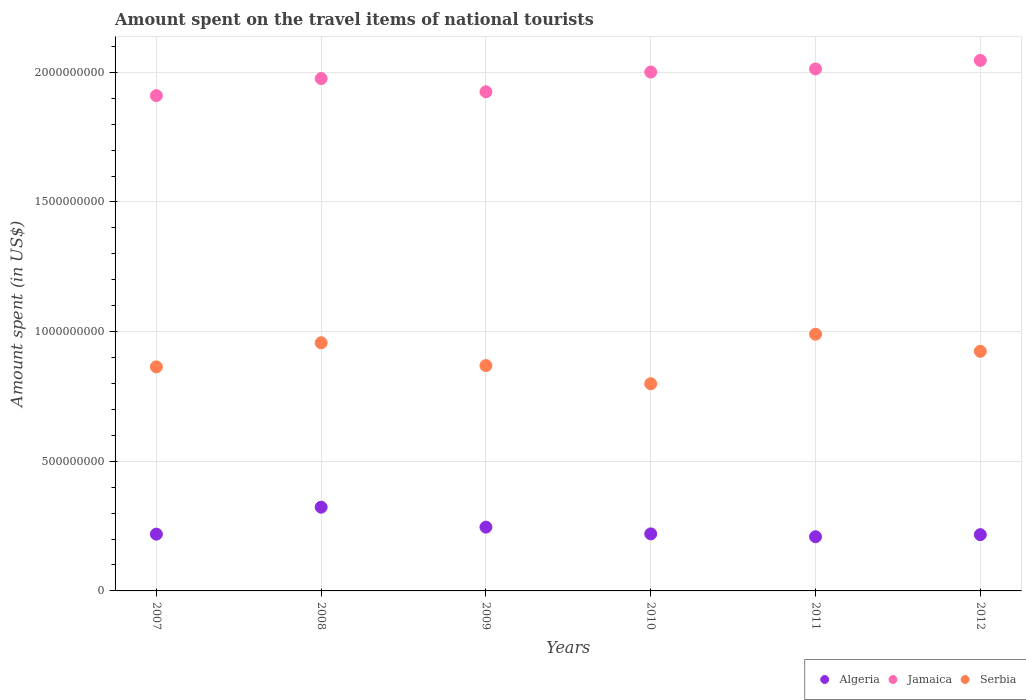What is the amount spent on the travel items of national tourists in Serbia in 2011?
Offer a very short reply. 9.90e+08. Across all years, what is the maximum amount spent on the travel items of national tourists in Serbia?
Provide a short and direct response. 9.90e+08. Across all years, what is the minimum amount spent on the travel items of national tourists in Serbia?
Offer a terse response. 7.99e+08. In which year was the amount spent on the travel items of national tourists in Jamaica maximum?
Your answer should be very brief. 2012. In which year was the amount spent on the travel items of national tourists in Jamaica minimum?
Your response must be concise. 2007. What is the total amount spent on the travel items of national tourists in Algeria in the graph?
Your answer should be compact. 1.43e+09. What is the difference between the amount spent on the travel items of national tourists in Jamaica in 2010 and that in 2012?
Make the answer very short. -4.50e+07. What is the difference between the amount spent on the travel items of national tourists in Jamaica in 2011 and the amount spent on the travel items of national tourists in Algeria in 2009?
Provide a short and direct response. 1.77e+09. What is the average amount spent on the travel items of national tourists in Algeria per year?
Provide a succinct answer. 2.39e+08. In the year 2011, what is the difference between the amount spent on the travel items of national tourists in Serbia and amount spent on the travel items of national tourists in Algeria?
Your answer should be compact. 7.81e+08. What is the ratio of the amount spent on the travel items of national tourists in Jamaica in 2009 to that in 2011?
Make the answer very short. 0.96. Is the amount spent on the travel items of national tourists in Serbia in 2007 less than that in 2008?
Your answer should be very brief. Yes. Is the difference between the amount spent on the travel items of national tourists in Serbia in 2009 and 2011 greater than the difference between the amount spent on the travel items of national tourists in Algeria in 2009 and 2011?
Make the answer very short. No. What is the difference between the highest and the second highest amount spent on the travel items of national tourists in Serbia?
Provide a short and direct response. 3.30e+07. What is the difference between the highest and the lowest amount spent on the travel items of national tourists in Serbia?
Your response must be concise. 1.91e+08. In how many years, is the amount spent on the travel items of national tourists in Serbia greater than the average amount spent on the travel items of national tourists in Serbia taken over all years?
Give a very brief answer. 3. Is the sum of the amount spent on the travel items of national tourists in Jamaica in 2009 and 2012 greater than the maximum amount spent on the travel items of national tourists in Algeria across all years?
Ensure brevity in your answer.  Yes. Is the amount spent on the travel items of national tourists in Serbia strictly less than the amount spent on the travel items of national tourists in Algeria over the years?
Your answer should be very brief. No. How many years are there in the graph?
Keep it short and to the point. 6. What is the difference between two consecutive major ticks on the Y-axis?
Keep it short and to the point. 5.00e+08. Are the values on the major ticks of Y-axis written in scientific E-notation?
Keep it short and to the point. No. Does the graph contain grids?
Provide a short and direct response. Yes. Where does the legend appear in the graph?
Ensure brevity in your answer.  Bottom right. What is the title of the graph?
Keep it short and to the point. Amount spent on the travel items of national tourists. Does "Brazil" appear as one of the legend labels in the graph?
Keep it short and to the point. No. What is the label or title of the Y-axis?
Ensure brevity in your answer.  Amount spent (in US$). What is the Amount spent (in US$) in Algeria in 2007?
Provide a short and direct response. 2.19e+08. What is the Amount spent (in US$) in Jamaica in 2007?
Give a very brief answer. 1.91e+09. What is the Amount spent (in US$) in Serbia in 2007?
Offer a very short reply. 8.64e+08. What is the Amount spent (in US$) of Algeria in 2008?
Make the answer very short. 3.23e+08. What is the Amount spent (in US$) of Jamaica in 2008?
Offer a terse response. 1.98e+09. What is the Amount spent (in US$) in Serbia in 2008?
Keep it short and to the point. 9.57e+08. What is the Amount spent (in US$) of Algeria in 2009?
Keep it short and to the point. 2.46e+08. What is the Amount spent (in US$) in Jamaica in 2009?
Your answer should be compact. 1.92e+09. What is the Amount spent (in US$) in Serbia in 2009?
Your answer should be compact. 8.69e+08. What is the Amount spent (in US$) of Algeria in 2010?
Your answer should be compact. 2.20e+08. What is the Amount spent (in US$) of Jamaica in 2010?
Make the answer very short. 2.00e+09. What is the Amount spent (in US$) in Serbia in 2010?
Offer a very short reply. 7.99e+08. What is the Amount spent (in US$) in Algeria in 2011?
Offer a very short reply. 2.09e+08. What is the Amount spent (in US$) in Jamaica in 2011?
Your response must be concise. 2.01e+09. What is the Amount spent (in US$) in Serbia in 2011?
Ensure brevity in your answer.  9.90e+08. What is the Amount spent (in US$) in Algeria in 2012?
Your response must be concise. 2.17e+08. What is the Amount spent (in US$) in Jamaica in 2012?
Ensure brevity in your answer.  2.05e+09. What is the Amount spent (in US$) of Serbia in 2012?
Make the answer very short. 9.24e+08. Across all years, what is the maximum Amount spent (in US$) in Algeria?
Make the answer very short. 3.23e+08. Across all years, what is the maximum Amount spent (in US$) in Jamaica?
Offer a terse response. 2.05e+09. Across all years, what is the maximum Amount spent (in US$) of Serbia?
Ensure brevity in your answer.  9.90e+08. Across all years, what is the minimum Amount spent (in US$) in Algeria?
Provide a short and direct response. 2.09e+08. Across all years, what is the minimum Amount spent (in US$) of Jamaica?
Your response must be concise. 1.91e+09. Across all years, what is the minimum Amount spent (in US$) of Serbia?
Keep it short and to the point. 7.99e+08. What is the total Amount spent (in US$) in Algeria in the graph?
Give a very brief answer. 1.43e+09. What is the total Amount spent (in US$) in Jamaica in the graph?
Give a very brief answer. 1.19e+1. What is the total Amount spent (in US$) in Serbia in the graph?
Offer a terse response. 5.40e+09. What is the difference between the Amount spent (in US$) of Algeria in 2007 and that in 2008?
Offer a terse response. -1.04e+08. What is the difference between the Amount spent (in US$) of Jamaica in 2007 and that in 2008?
Ensure brevity in your answer.  -6.60e+07. What is the difference between the Amount spent (in US$) in Serbia in 2007 and that in 2008?
Your response must be concise. -9.30e+07. What is the difference between the Amount spent (in US$) of Algeria in 2007 and that in 2009?
Your response must be concise. -2.70e+07. What is the difference between the Amount spent (in US$) of Jamaica in 2007 and that in 2009?
Your answer should be very brief. -1.50e+07. What is the difference between the Amount spent (in US$) of Serbia in 2007 and that in 2009?
Your answer should be compact. -5.00e+06. What is the difference between the Amount spent (in US$) of Jamaica in 2007 and that in 2010?
Offer a terse response. -9.10e+07. What is the difference between the Amount spent (in US$) of Serbia in 2007 and that in 2010?
Keep it short and to the point. 6.50e+07. What is the difference between the Amount spent (in US$) of Jamaica in 2007 and that in 2011?
Your answer should be very brief. -1.03e+08. What is the difference between the Amount spent (in US$) in Serbia in 2007 and that in 2011?
Offer a terse response. -1.26e+08. What is the difference between the Amount spent (in US$) in Jamaica in 2007 and that in 2012?
Provide a short and direct response. -1.36e+08. What is the difference between the Amount spent (in US$) of Serbia in 2007 and that in 2012?
Give a very brief answer. -6.00e+07. What is the difference between the Amount spent (in US$) in Algeria in 2008 and that in 2009?
Keep it short and to the point. 7.70e+07. What is the difference between the Amount spent (in US$) of Jamaica in 2008 and that in 2009?
Your answer should be compact. 5.10e+07. What is the difference between the Amount spent (in US$) in Serbia in 2008 and that in 2009?
Provide a short and direct response. 8.80e+07. What is the difference between the Amount spent (in US$) in Algeria in 2008 and that in 2010?
Give a very brief answer. 1.03e+08. What is the difference between the Amount spent (in US$) in Jamaica in 2008 and that in 2010?
Keep it short and to the point. -2.50e+07. What is the difference between the Amount spent (in US$) in Serbia in 2008 and that in 2010?
Provide a succinct answer. 1.58e+08. What is the difference between the Amount spent (in US$) in Algeria in 2008 and that in 2011?
Your answer should be very brief. 1.14e+08. What is the difference between the Amount spent (in US$) in Jamaica in 2008 and that in 2011?
Make the answer very short. -3.70e+07. What is the difference between the Amount spent (in US$) of Serbia in 2008 and that in 2011?
Your answer should be very brief. -3.30e+07. What is the difference between the Amount spent (in US$) in Algeria in 2008 and that in 2012?
Make the answer very short. 1.06e+08. What is the difference between the Amount spent (in US$) in Jamaica in 2008 and that in 2012?
Offer a very short reply. -7.00e+07. What is the difference between the Amount spent (in US$) of Serbia in 2008 and that in 2012?
Your answer should be very brief. 3.30e+07. What is the difference between the Amount spent (in US$) in Algeria in 2009 and that in 2010?
Your answer should be compact. 2.60e+07. What is the difference between the Amount spent (in US$) in Jamaica in 2009 and that in 2010?
Ensure brevity in your answer.  -7.60e+07. What is the difference between the Amount spent (in US$) of Serbia in 2009 and that in 2010?
Your answer should be very brief. 7.00e+07. What is the difference between the Amount spent (in US$) of Algeria in 2009 and that in 2011?
Ensure brevity in your answer.  3.70e+07. What is the difference between the Amount spent (in US$) in Jamaica in 2009 and that in 2011?
Your response must be concise. -8.80e+07. What is the difference between the Amount spent (in US$) of Serbia in 2009 and that in 2011?
Provide a short and direct response. -1.21e+08. What is the difference between the Amount spent (in US$) of Algeria in 2009 and that in 2012?
Give a very brief answer. 2.90e+07. What is the difference between the Amount spent (in US$) of Jamaica in 2009 and that in 2012?
Your answer should be compact. -1.21e+08. What is the difference between the Amount spent (in US$) in Serbia in 2009 and that in 2012?
Offer a terse response. -5.50e+07. What is the difference between the Amount spent (in US$) of Algeria in 2010 and that in 2011?
Make the answer very short. 1.10e+07. What is the difference between the Amount spent (in US$) of Jamaica in 2010 and that in 2011?
Ensure brevity in your answer.  -1.20e+07. What is the difference between the Amount spent (in US$) of Serbia in 2010 and that in 2011?
Ensure brevity in your answer.  -1.91e+08. What is the difference between the Amount spent (in US$) in Jamaica in 2010 and that in 2012?
Ensure brevity in your answer.  -4.50e+07. What is the difference between the Amount spent (in US$) in Serbia in 2010 and that in 2012?
Your answer should be very brief. -1.25e+08. What is the difference between the Amount spent (in US$) of Algeria in 2011 and that in 2012?
Provide a short and direct response. -8.00e+06. What is the difference between the Amount spent (in US$) in Jamaica in 2011 and that in 2012?
Ensure brevity in your answer.  -3.30e+07. What is the difference between the Amount spent (in US$) in Serbia in 2011 and that in 2012?
Provide a short and direct response. 6.60e+07. What is the difference between the Amount spent (in US$) in Algeria in 2007 and the Amount spent (in US$) in Jamaica in 2008?
Your answer should be compact. -1.76e+09. What is the difference between the Amount spent (in US$) of Algeria in 2007 and the Amount spent (in US$) of Serbia in 2008?
Ensure brevity in your answer.  -7.38e+08. What is the difference between the Amount spent (in US$) in Jamaica in 2007 and the Amount spent (in US$) in Serbia in 2008?
Give a very brief answer. 9.53e+08. What is the difference between the Amount spent (in US$) in Algeria in 2007 and the Amount spent (in US$) in Jamaica in 2009?
Keep it short and to the point. -1.71e+09. What is the difference between the Amount spent (in US$) of Algeria in 2007 and the Amount spent (in US$) of Serbia in 2009?
Give a very brief answer. -6.50e+08. What is the difference between the Amount spent (in US$) in Jamaica in 2007 and the Amount spent (in US$) in Serbia in 2009?
Make the answer very short. 1.04e+09. What is the difference between the Amount spent (in US$) of Algeria in 2007 and the Amount spent (in US$) of Jamaica in 2010?
Your response must be concise. -1.78e+09. What is the difference between the Amount spent (in US$) in Algeria in 2007 and the Amount spent (in US$) in Serbia in 2010?
Your answer should be compact. -5.80e+08. What is the difference between the Amount spent (in US$) of Jamaica in 2007 and the Amount spent (in US$) of Serbia in 2010?
Provide a short and direct response. 1.11e+09. What is the difference between the Amount spent (in US$) of Algeria in 2007 and the Amount spent (in US$) of Jamaica in 2011?
Your answer should be very brief. -1.79e+09. What is the difference between the Amount spent (in US$) of Algeria in 2007 and the Amount spent (in US$) of Serbia in 2011?
Provide a succinct answer. -7.71e+08. What is the difference between the Amount spent (in US$) in Jamaica in 2007 and the Amount spent (in US$) in Serbia in 2011?
Offer a terse response. 9.20e+08. What is the difference between the Amount spent (in US$) in Algeria in 2007 and the Amount spent (in US$) in Jamaica in 2012?
Offer a very short reply. -1.83e+09. What is the difference between the Amount spent (in US$) of Algeria in 2007 and the Amount spent (in US$) of Serbia in 2012?
Make the answer very short. -7.05e+08. What is the difference between the Amount spent (in US$) of Jamaica in 2007 and the Amount spent (in US$) of Serbia in 2012?
Your answer should be compact. 9.86e+08. What is the difference between the Amount spent (in US$) of Algeria in 2008 and the Amount spent (in US$) of Jamaica in 2009?
Offer a very short reply. -1.60e+09. What is the difference between the Amount spent (in US$) in Algeria in 2008 and the Amount spent (in US$) in Serbia in 2009?
Offer a terse response. -5.46e+08. What is the difference between the Amount spent (in US$) of Jamaica in 2008 and the Amount spent (in US$) of Serbia in 2009?
Give a very brief answer. 1.11e+09. What is the difference between the Amount spent (in US$) in Algeria in 2008 and the Amount spent (in US$) in Jamaica in 2010?
Your answer should be very brief. -1.68e+09. What is the difference between the Amount spent (in US$) of Algeria in 2008 and the Amount spent (in US$) of Serbia in 2010?
Your answer should be very brief. -4.76e+08. What is the difference between the Amount spent (in US$) of Jamaica in 2008 and the Amount spent (in US$) of Serbia in 2010?
Keep it short and to the point. 1.18e+09. What is the difference between the Amount spent (in US$) in Algeria in 2008 and the Amount spent (in US$) in Jamaica in 2011?
Keep it short and to the point. -1.69e+09. What is the difference between the Amount spent (in US$) in Algeria in 2008 and the Amount spent (in US$) in Serbia in 2011?
Give a very brief answer. -6.67e+08. What is the difference between the Amount spent (in US$) of Jamaica in 2008 and the Amount spent (in US$) of Serbia in 2011?
Offer a terse response. 9.86e+08. What is the difference between the Amount spent (in US$) in Algeria in 2008 and the Amount spent (in US$) in Jamaica in 2012?
Make the answer very short. -1.72e+09. What is the difference between the Amount spent (in US$) of Algeria in 2008 and the Amount spent (in US$) of Serbia in 2012?
Your response must be concise. -6.01e+08. What is the difference between the Amount spent (in US$) of Jamaica in 2008 and the Amount spent (in US$) of Serbia in 2012?
Your answer should be very brief. 1.05e+09. What is the difference between the Amount spent (in US$) in Algeria in 2009 and the Amount spent (in US$) in Jamaica in 2010?
Give a very brief answer. -1.76e+09. What is the difference between the Amount spent (in US$) in Algeria in 2009 and the Amount spent (in US$) in Serbia in 2010?
Offer a terse response. -5.53e+08. What is the difference between the Amount spent (in US$) of Jamaica in 2009 and the Amount spent (in US$) of Serbia in 2010?
Your response must be concise. 1.13e+09. What is the difference between the Amount spent (in US$) of Algeria in 2009 and the Amount spent (in US$) of Jamaica in 2011?
Provide a succinct answer. -1.77e+09. What is the difference between the Amount spent (in US$) of Algeria in 2009 and the Amount spent (in US$) of Serbia in 2011?
Your answer should be very brief. -7.44e+08. What is the difference between the Amount spent (in US$) in Jamaica in 2009 and the Amount spent (in US$) in Serbia in 2011?
Ensure brevity in your answer.  9.35e+08. What is the difference between the Amount spent (in US$) of Algeria in 2009 and the Amount spent (in US$) of Jamaica in 2012?
Ensure brevity in your answer.  -1.80e+09. What is the difference between the Amount spent (in US$) of Algeria in 2009 and the Amount spent (in US$) of Serbia in 2012?
Offer a terse response. -6.78e+08. What is the difference between the Amount spent (in US$) of Jamaica in 2009 and the Amount spent (in US$) of Serbia in 2012?
Your response must be concise. 1.00e+09. What is the difference between the Amount spent (in US$) of Algeria in 2010 and the Amount spent (in US$) of Jamaica in 2011?
Offer a very short reply. -1.79e+09. What is the difference between the Amount spent (in US$) in Algeria in 2010 and the Amount spent (in US$) in Serbia in 2011?
Provide a succinct answer. -7.70e+08. What is the difference between the Amount spent (in US$) in Jamaica in 2010 and the Amount spent (in US$) in Serbia in 2011?
Your answer should be very brief. 1.01e+09. What is the difference between the Amount spent (in US$) of Algeria in 2010 and the Amount spent (in US$) of Jamaica in 2012?
Your answer should be compact. -1.83e+09. What is the difference between the Amount spent (in US$) of Algeria in 2010 and the Amount spent (in US$) of Serbia in 2012?
Ensure brevity in your answer.  -7.04e+08. What is the difference between the Amount spent (in US$) of Jamaica in 2010 and the Amount spent (in US$) of Serbia in 2012?
Ensure brevity in your answer.  1.08e+09. What is the difference between the Amount spent (in US$) of Algeria in 2011 and the Amount spent (in US$) of Jamaica in 2012?
Your response must be concise. -1.84e+09. What is the difference between the Amount spent (in US$) in Algeria in 2011 and the Amount spent (in US$) in Serbia in 2012?
Your answer should be compact. -7.15e+08. What is the difference between the Amount spent (in US$) in Jamaica in 2011 and the Amount spent (in US$) in Serbia in 2012?
Your answer should be compact. 1.09e+09. What is the average Amount spent (in US$) of Algeria per year?
Your answer should be very brief. 2.39e+08. What is the average Amount spent (in US$) of Jamaica per year?
Provide a short and direct response. 1.98e+09. What is the average Amount spent (in US$) in Serbia per year?
Your answer should be compact. 9.00e+08. In the year 2007, what is the difference between the Amount spent (in US$) of Algeria and Amount spent (in US$) of Jamaica?
Provide a succinct answer. -1.69e+09. In the year 2007, what is the difference between the Amount spent (in US$) of Algeria and Amount spent (in US$) of Serbia?
Offer a very short reply. -6.45e+08. In the year 2007, what is the difference between the Amount spent (in US$) of Jamaica and Amount spent (in US$) of Serbia?
Provide a short and direct response. 1.05e+09. In the year 2008, what is the difference between the Amount spent (in US$) in Algeria and Amount spent (in US$) in Jamaica?
Ensure brevity in your answer.  -1.65e+09. In the year 2008, what is the difference between the Amount spent (in US$) of Algeria and Amount spent (in US$) of Serbia?
Your answer should be compact. -6.34e+08. In the year 2008, what is the difference between the Amount spent (in US$) of Jamaica and Amount spent (in US$) of Serbia?
Offer a terse response. 1.02e+09. In the year 2009, what is the difference between the Amount spent (in US$) in Algeria and Amount spent (in US$) in Jamaica?
Offer a very short reply. -1.68e+09. In the year 2009, what is the difference between the Amount spent (in US$) in Algeria and Amount spent (in US$) in Serbia?
Give a very brief answer. -6.23e+08. In the year 2009, what is the difference between the Amount spent (in US$) in Jamaica and Amount spent (in US$) in Serbia?
Give a very brief answer. 1.06e+09. In the year 2010, what is the difference between the Amount spent (in US$) of Algeria and Amount spent (in US$) of Jamaica?
Offer a terse response. -1.78e+09. In the year 2010, what is the difference between the Amount spent (in US$) in Algeria and Amount spent (in US$) in Serbia?
Provide a short and direct response. -5.79e+08. In the year 2010, what is the difference between the Amount spent (in US$) in Jamaica and Amount spent (in US$) in Serbia?
Your answer should be compact. 1.20e+09. In the year 2011, what is the difference between the Amount spent (in US$) in Algeria and Amount spent (in US$) in Jamaica?
Provide a succinct answer. -1.80e+09. In the year 2011, what is the difference between the Amount spent (in US$) of Algeria and Amount spent (in US$) of Serbia?
Provide a short and direct response. -7.81e+08. In the year 2011, what is the difference between the Amount spent (in US$) of Jamaica and Amount spent (in US$) of Serbia?
Offer a terse response. 1.02e+09. In the year 2012, what is the difference between the Amount spent (in US$) of Algeria and Amount spent (in US$) of Jamaica?
Give a very brief answer. -1.83e+09. In the year 2012, what is the difference between the Amount spent (in US$) in Algeria and Amount spent (in US$) in Serbia?
Your answer should be compact. -7.07e+08. In the year 2012, what is the difference between the Amount spent (in US$) in Jamaica and Amount spent (in US$) in Serbia?
Provide a short and direct response. 1.12e+09. What is the ratio of the Amount spent (in US$) of Algeria in 2007 to that in 2008?
Your answer should be very brief. 0.68. What is the ratio of the Amount spent (in US$) in Jamaica in 2007 to that in 2008?
Offer a terse response. 0.97. What is the ratio of the Amount spent (in US$) in Serbia in 2007 to that in 2008?
Your response must be concise. 0.9. What is the ratio of the Amount spent (in US$) of Algeria in 2007 to that in 2009?
Make the answer very short. 0.89. What is the ratio of the Amount spent (in US$) in Algeria in 2007 to that in 2010?
Your response must be concise. 1. What is the ratio of the Amount spent (in US$) in Jamaica in 2007 to that in 2010?
Offer a very short reply. 0.95. What is the ratio of the Amount spent (in US$) in Serbia in 2007 to that in 2010?
Provide a short and direct response. 1.08. What is the ratio of the Amount spent (in US$) in Algeria in 2007 to that in 2011?
Offer a very short reply. 1.05. What is the ratio of the Amount spent (in US$) of Jamaica in 2007 to that in 2011?
Keep it short and to the point. 0.95. What is the ratio of the Amount spent (in US$) of Serbia in 2007 to that in 2011?
Your response must be concise. 0.87. What is the ratio of the Amount spent (in US$) of Algeria in 2007 to that in 2012?
Make the answer very short. 1.01. What is the ratio of the Amount spent (in US$) in Jamaica in 2007 to that in 2012?
Provide a succinct answer. 0.93. What is the ratio of the Amount spent (in US$) of Serbia in 2007 to that in 2012?
Your response must be concise. 0.94. What is the ratio of the Amount spent (in US$) in Algeria in 2008 to that in 2009?
Give a very brief answer. 1.31. What is the ratio of the Amount spent (in US$) in Jamaica in 2008 to that in 2009?
Give a very brief answer. 1.03. What is the ratio of the Amount spent (in US$) of Serbia in 2008 to that in 2009?
Give a very brief answer. 1.1. What is the ratio of the Amount spent (in US$) of Algeria in 2008 to that in 2010?
Make the answer very short. 1.47. What is the ratio of the Amount spent (in US$) in Jamaica in 2008 to that in 2010?
Your response must be concise. 0.99. What is the ratio of the Amount spent (in US$) in Serbia in 2008 to that in 2010?
Your answer should be compact. 1.2. What is the ratio of the Amount spent (in US$) of Algeria in 2008 to that in 2011?
Give a very brief answer. 1.55. What is the ratio of the Amount spent (in US$) of Jamaica in 2008 to that in 2011?
Make the answer very short. 0.98. What is the ratio of the Amount spent (in US$) of Serbia in 2008 to that in 2011?
Your response must be concise. 0.97. What is the ratio of the Amount spent (in US$) in Algeria in 2008 to that in 2012?
Your response must be concise. 1.49. What is the ratio of the Amount spent (in US$) in Jamaica in 2008 to that in 2012?
Your response must be concise. 0.97. What is the ratio of the Amount spent (in US$) of Serbia in 2008 to that in 2012?
Provide a short and direct response. 1.04. What is the ratio of the Amount spent (in US$) in Algeria in 2009 to that in 2010?
Provide a succinct answer. 1.12. What is the ratio of the Amount spent (in US$) in Serbia in 2009 to that in 2010?
Offer a very short reply. 1.09. What is the ratio of the Amount spent (in US$) of Algeria in 2009 to that in 2011?
Keep it short and to the point. 1.18. What is the ratio of the Amount spent (in US$) in Jamaica in 2009 to that in 2011?
Offer a terse response. 0.96. What is the ratio of the Amount spent (in US$) of Serbia in 2009 to that in 2011?
Provide a short and direct response. 0.88. What is the ratio of the Amount spent (in US$) of Algeria in 2009 to that in 2012?
Provide a succinct answer. 1.13. What is the ratio of the Amount spent (in US$) of Jamaica in 2009 to that in 2012?
Keep it short and to the point. 0.94. What is the ratio of the Amount spent (in US$) of Serbia in 2009 to that in 2012?
Keep it short and to the point. 0.94. What is the ratio of the Amount spent (in US$) of Algeria in 2010 to that in 2011?
Offer a very short reply. 1.05. What is the ratio of the Amount spent (in US$) of Serbia in 2010 to that in 2011?
Keep it short and to the point. 0.81. What is the ratio of the Amount spent (in US$) of Algeria in 2010 to that in 2012?
Provide a succinct answer. 1.01. What is the ratio of the Amount spent (in US$) of Jamaica in 2010 to that in 2012?
Offer a very short reply. 0.98. What is the ratio of the Amount spent (in US$) in Serbia in 2010 to that in 2012?
Offer a very short reply. 0.86. What is the ratio of the Amount spent (in US$) of Algeria in 2011 to that in 2012?
Your answer should be very brief. 0.96. What is the ratio of the Amount spent (in US$) in Jamaica in 2011 to that in 2012?
Keep it short and to the point. 0.98. What is the ratio of the Amount spent (in US$) in Serbia in 2011 to that in 2012?
Your answer should be very brief. 1.07. What is the difference between the highest and the second highest Amount spent (in US$) in Algeria?
Provide a short and direct response. 7.70e+07. What is the difference between the highest and the second highest Amount spent (in US$) in Jamaica?
Your response must be concise. 3.30e+07. What is the difference between the highest and the second highest Amount spent (in US$) of Serbia?
Offer a very short reply. 3.30e+07. What is the difference between the highest and the lowest Amount spent (in US$) of Algeria?
Provide a short and direct response. 1.14e+08. What is the difference between the highest and the lowest Amount spent (in US$) of Jamaica?
Your answer should be compact. 1.36e+08. What is the difference between the highest and the lowest Amount spent (in US$) of Serbia?
Offer a terse response. 1.91e+08. 